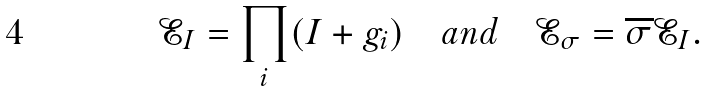Convert formula to latex. <formula><loc_0><loc_0><loc_500><loc_500>\mathcal { E } _ { I } = \prod _ { i } ( I + g _ { i } ) \quad a n d \quad \mathcal { E } _ { \sigma } = \overline { \sigma } \mathcal { E } _ { I } .</formula> 